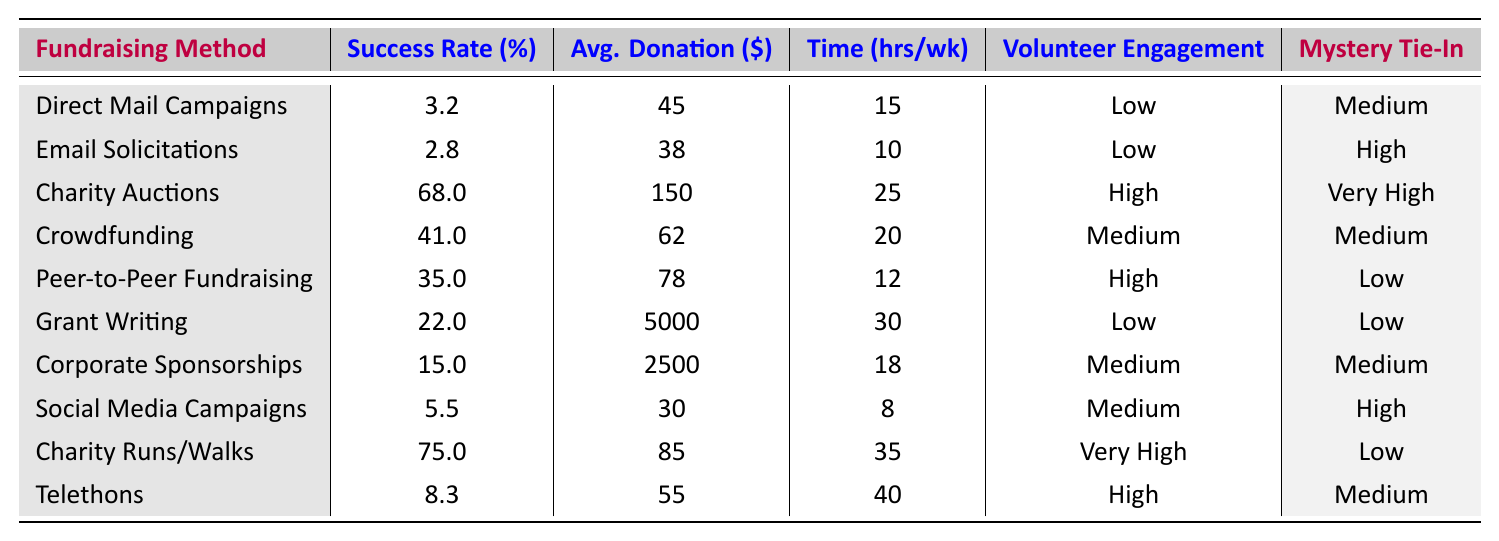What is the success rate of Charity Auctions? The table indicates a success rate of 68% for Charity Auctions.
Answer: 68% Which fundraising method has the highest average donation? The table shows that Grant Writing has the highest average donation at $5000.
Answer: $5000 How many hours per week does a typical Charity Run/Walk require? According to the table, a typical Charity Run/Walk requires 35 hours per week.
Answer: 35 Is the volunteer engagement level for Peer-to-Peer Fundraising high? The table states that the volunteer engagement level for Peer-to-Peer Fundraising is high.
Answer: Yes What is the average success rate of Social Media Campaigns and Email Solicitations combined? The success rates for Social Media Campaigns and Email Solicitations are 5.5% and 2.8%, respectively. Their average is (5.5 + 2.8) / 2 = 4.15%.
Answer: 4.15% Which fundraising method has the lowest success rate? By inspecting the table, Email Solicitations has the lowest success rate at 2.8%.
Answer: 2.8% Identify the fundraising method with medium mystery novel tie-in potential that has high volunteer engagement. The table shows that Crowdfunding is the method with medium mystery novel tie-in potential and high volunteer engagement.
Answer: Crowdfunding How does the success rate of Charity Auctions compare to that of Corporate Sponsorships? The success rate for Charity Auctions is 68%, while Corporate Sponsorships have a success rate of 15%. Charity Auctions are significantly more successful than Corporate Sponsorships.
Answer: Charity Auctions are significantly more successful What is the total average donation for the top three successful fundraising methods? The top three methods by success rate are Charity Auctions (150), Charity Runs/Walks (85), and Crowdfunding (62). Adding these gives 150 + 85 + 62 = 297.
Answer: $297 What percentage of fundraising methods have a low volunteer engagement level? There are two methods with low volunteer engagement: Direct Mail Campaigns and Grant Writing, out of ten total methods. Thus, the percentage is (2/10) * 100 = 20%.
Answer: 20% 